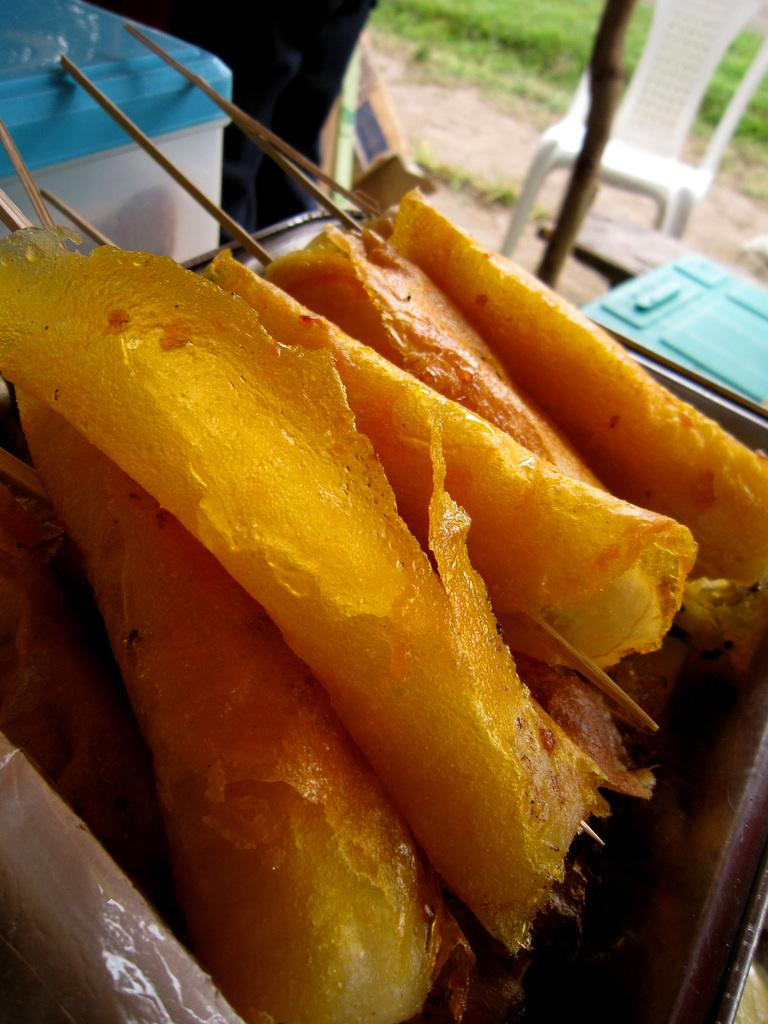What is inside the container that can be seen in the image? There is a container with food items in the image. What type of furniture is present in the image? There is a white chair in the image. What material is visible in the image? Wood is present in the image. What can be seen beneath the objects in the image? The ground is visible in the image. What type of vegetation is present in the image? There is grass in the image. What rhythm is the knee tapping in the image? There is no knee or rhythm present in the image. 